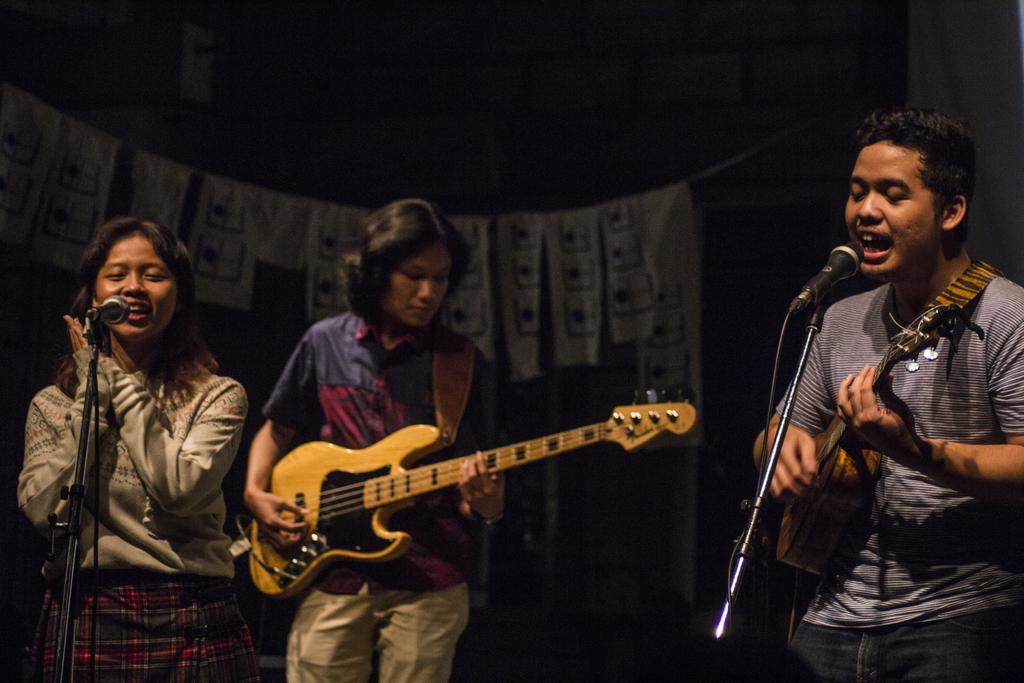Could you give a brief overview of what you see in this image? In this image there are three persons who are playing musical instruments and singing together. 